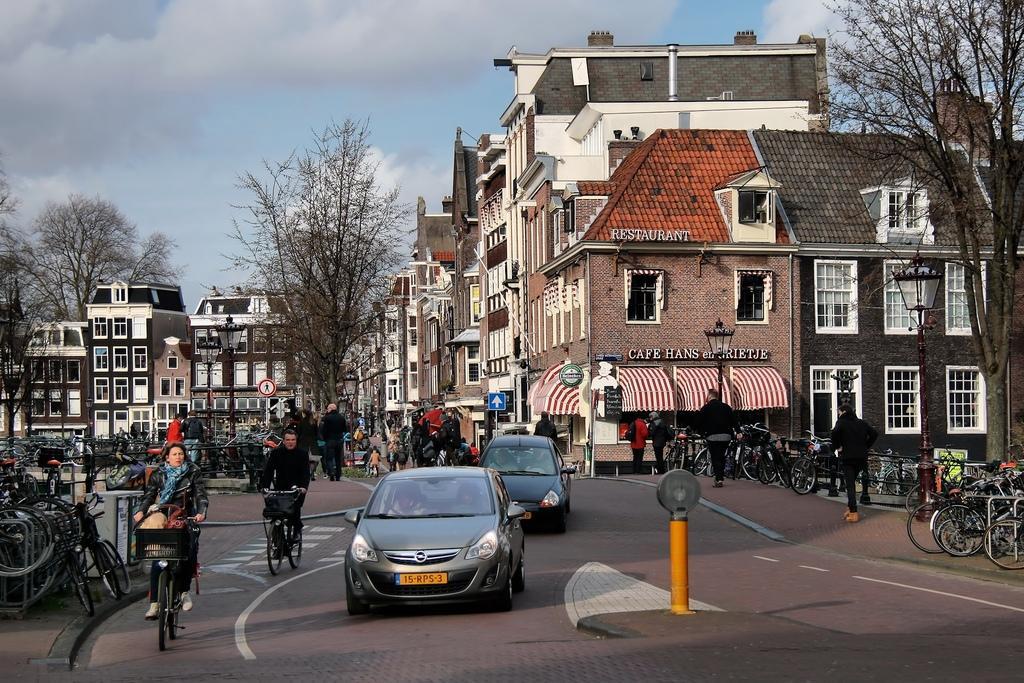In one or two sentences, can you explain what this image depicts? In this image we can see a road. There are many vehicles. Few people are riding cycles. On the sides of the road there are cycles, buildings with windows and names. Also there are trees. In the background there is sky with clouds. Also there are sign boards. 